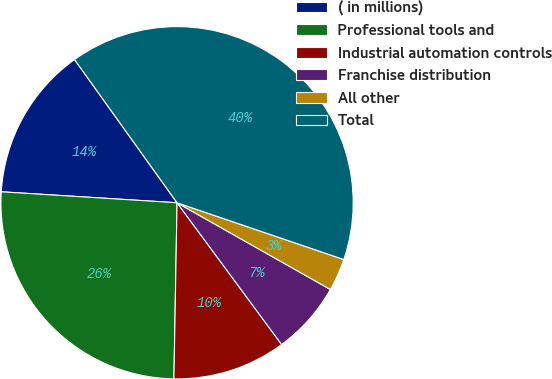<chart> <loc_0><loc_0><loc_500><loc_500><pie_chart><fcel>( in millions)<fcel>Professional tools and<fcel>Industrial automation controls<fcel>Franchise distribution<fcel>All other<fcel>Total<nl><fcel>14.12%<fcel>25.71%<fcel>10.4%<fcel>6.69%<fcel>2.97%<fcel>40.11%<nl></chart> 